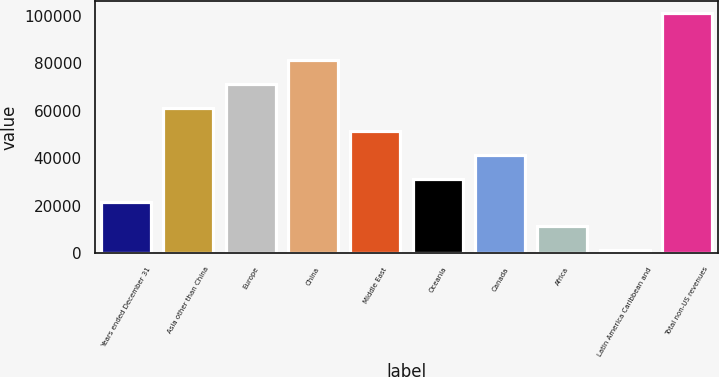<chart> <loc_0><loc_0><loc_500><loc_500><bar_chart><fcel>Years ended December 31<fcel>Asia other than China<fcel>Europe<fcel>China<fcel>Middle East<fcel>Oceania<fcel>Canada<fcel>Africa<fcel>Latin America Caribbean and<fcel>Total non-US revenues<nl><fcel>21391.8<fcel>61259.4<fcel>71226.3<fcel>81193.2<fcel>51292.5<fcel>31358.7<fcel>41325.6<fcel>11424.9<fcel>1458<fcel>101127<nl></chart> 